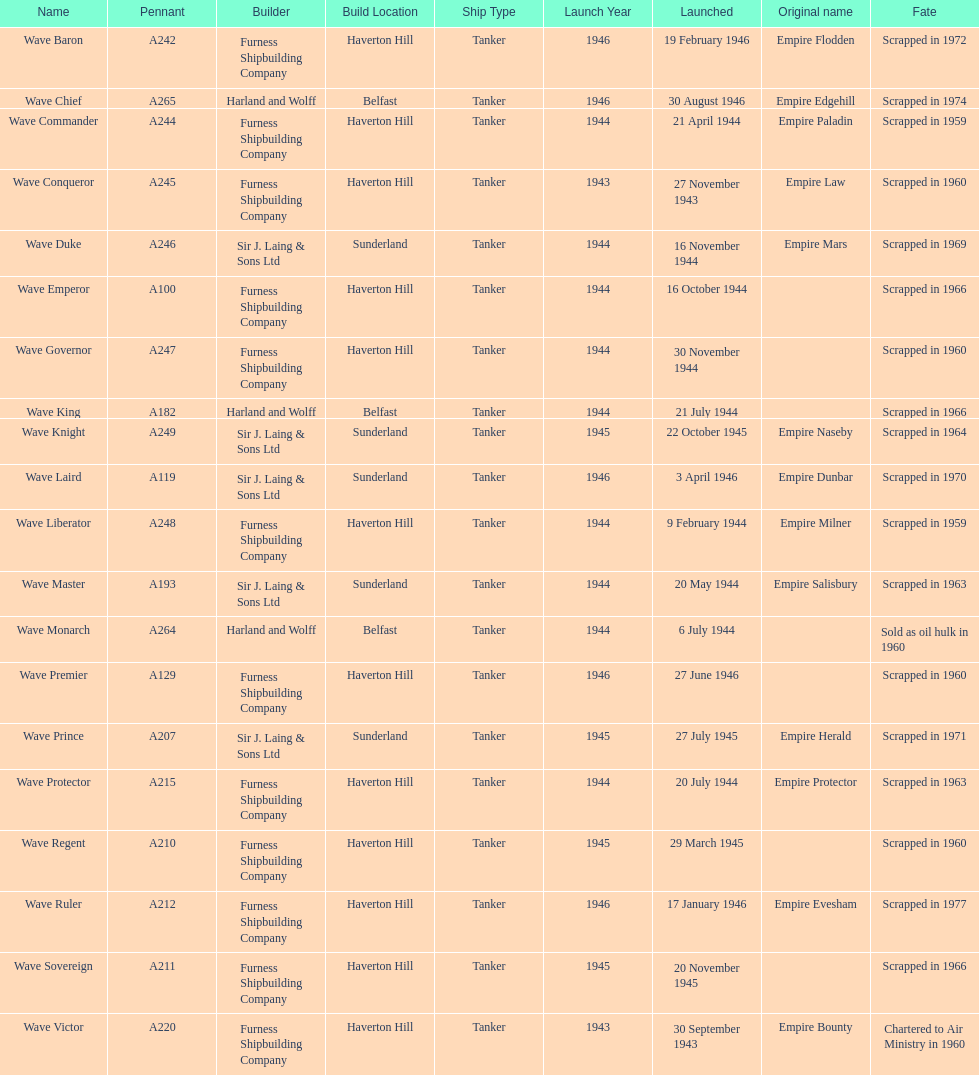Can you parse all the data within this table? {'header': ['Name', 'Pennant', 'Builder', 'Build Location', 'Ship Type', 'Launch Year', 'Launched', 'Original name', 'Fate'], 'rows': [['Wave Baron', 'A242', 'Furness Shipbuilding Company', 'Haverton Hill', 'Tanker', '1946', '19 February 1946', 'Empire Flodden', 'Scrapped in 1972'], ['Wave Chief', 'A265', 'Harland and Wolff', 'Belfast', 'Tanker', '1946', '30 August 1946', 'Empire Edgehill', 'Scrapped in 1974'], ['Wave Commander', 'A244', 'Furness Shipbuilding Company', 'Haverton Hill', 'Tanker', '1944', '21 April 1944', 'Empire Paladin', 'Scrapped in 1959'], ['Wave Conqueror', 'A245', 'Furness Shipbuilding Company', 'Haverton Hill', 'Tanker', '1943', '27 November 1943', 'Empire Law', 'Scrapped in 1960'], ['Wave Duke', 'A246', 'Sir J. Laing & Sons Ltd', 'Sunderland', 'Tanker', '1944', '16 November 1944', 'Empire Mars', 'Scrapped in 1969'], ['Wave Emperor', 'A100', 'Furness Shipbuilding Company', 'Haverton Hill', 'Tanker', '1944', '16 October 1944', '', 'Scrapped in 1966'], ['Wave Governor', 'A247', 'Furness Shipbuilding Company', 'Haverton Hill', 'Tanker', '1944', '30 November 1944', '', 'Scrapped in 1960'], ['Wave King', 'A182', 'Harland and Wolff', 'Belfast', 'Tanker', '1944', '21 July 1944', '', 'Scrapped in 1966'], ['Wave Knight', 'A249', 'Sir J. Laing & Sons Ltd', 'Sunderland', 'Tanker', '1945', '22 October 1945', 'Empire Naseby', 'Scrapped in 1964'], ['Wave Laird', 'A119', 'Sir J. Laing & Sons Ltd', 'Sunderland', 'Tanker', '1946', '3 April 1946', 'Empire Dunbar', 'Scrapped in 1970'], ['Wave Liberator', 'A248', 'Furness Shipbuilding Company', 'Haverton Hill', 'Tanker', '1944', '9 February 1944', 'Empire Milner', 'Scrapped in 1959'], ['Wave Master', 'A193', 'Sir J. Laing & Sons Ltd', 'Sunderland', 'Tanker', '1944', '20 May 1944', 'Empire Salisbury', 'Scrapped in 1963'], ['Wave Monarch', 'A264', 'Harland and Wolff', 'Belfast', 'Tanker', '1944', '6 July 1944', '', 'Sold as oil hulk in 1960'], ['Wave Premier', 'A129', 'Furness Shipbuilding Company', 'Haverton Hill', 'Tanker', '1946', '27 June 1946', '', 'Scrapped in 1960'], ['Wave Prince', 'A207', 'Sir J. Laing & Sons Ltd', 'Sunderland', 'Tanker', '1945', '27 July 1945', 'Empire Herald', 'Scrapped in 1971'], ['Wave Protector', 'A215', 'Furness Shipbuilding Company', 'Haverton Hill', 'Tanker', '1944', '20 July 1944', 'Empire Protector', 'Scrapped in 1963'], ['Wave Regent', 'A210', 'Furness Shipbuilding Company', 'Haverton Hill', 'Tanker', '1945', '29 March 1945', '', 'Scrapped in 1960'], ['Wave Ruler', 'A212', 'Furness Shipbuilding Company', 'Haverton Hill', 'Tanker', '1946', '17 January 1946', 'Empire Evesham', 'Scrapped in 1977'], ['Wave Sovereign', 'A211', 'Furness Shipbuilding Company', 'Haverton Hill', 'Tanker', '1945', '20 November 1945', '', 'Scrapped in 1966'], ['Wave Victor', 'A220', 'Furness Shipbuilding Company', 'Haverton Hill', 'Tanker', '1943', '30 September 1943', 'Empire Bounty', 'Chartered to Air Ministry in 1960']]} What date was the first ship launched? 30 September 1943. 